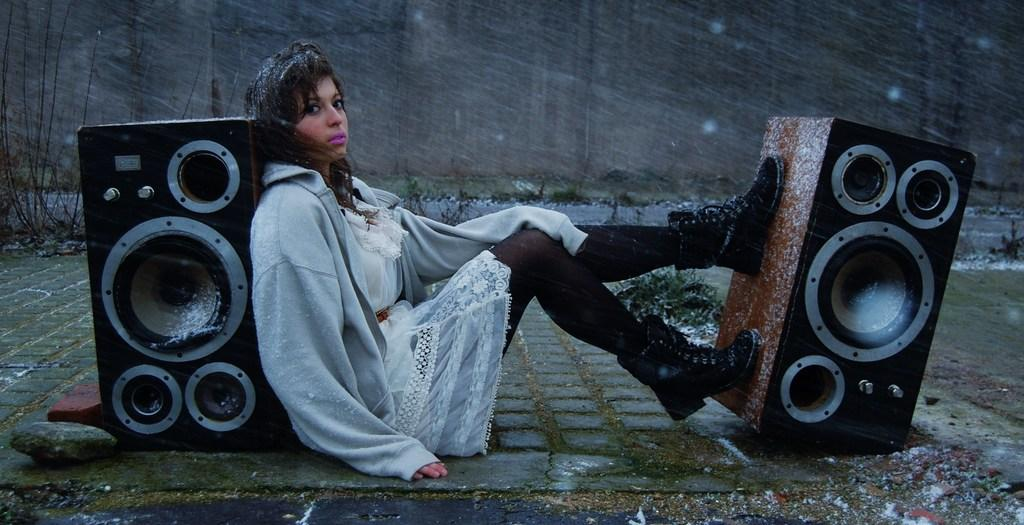What is the girl doing in the image? The girl is sitting on the land in the image. What objects are near the girl? There are two speakers, one on each side of the girl. What type of clothing is the girl wearing? The girl is wearing a sweatshirt and a cap. What can be seen in the background of the image? There is a wall in the background of the image. What type of pancake is the girl eating in the image? There is no pancake present in the image; the girl is sitting on the land and wearing a sweatshirt and a cap. 